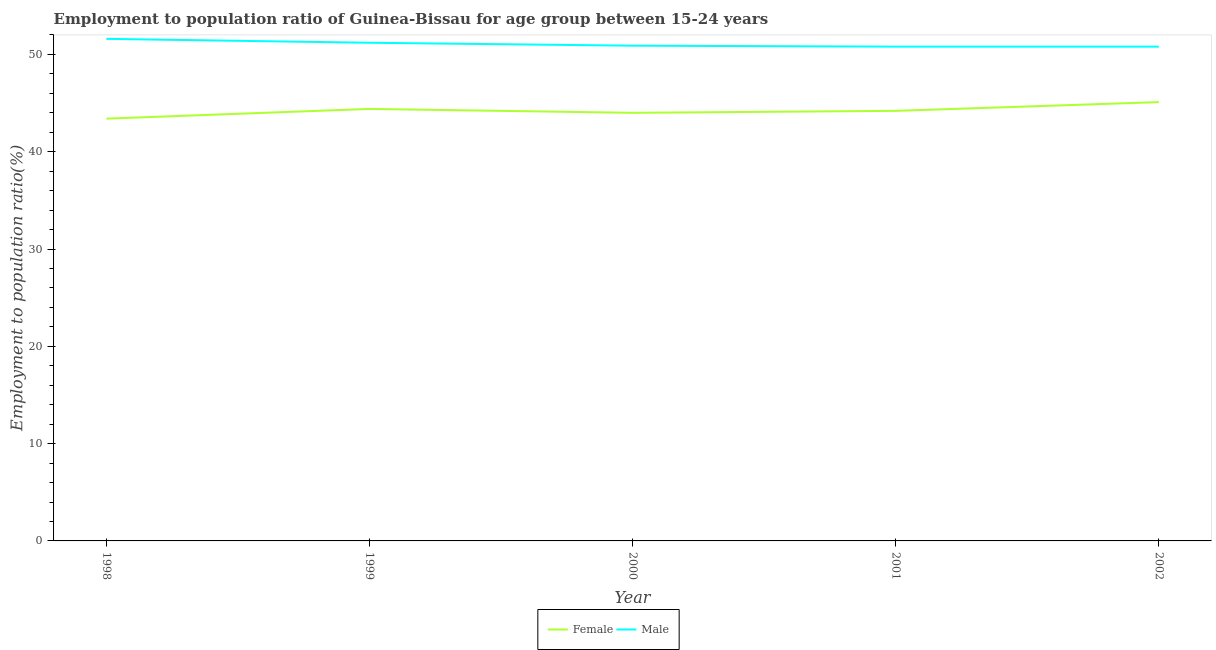Does the line corresponding to employment to population ratio(male) intersect with the line corresponding to employment to population ratio(female)?
Offer a very short reply. No. What is the employment to population ratio(female) in 1998?
Your response must be concise. 43.4. Across all years, what is the maximum employment to population ratio(male)?
Your response must be concise. 51.6. Across all years, what is the minimum employment to population ratio(male)?
Ensure brevity in your answer.  50.8. What is the total employment to population ratio(male) in the graph?
Offer a terse response. 255.3. What is the difference between the employment to population ratio(female) in 2000 and that in 2001?
Your answer should be very brief. -0.2. What is the difference between the employment to population ratio(female) in 2002 and the employment to population ratio(male) in 1999?
Your response must be concise. -6.1. What is the average employment to population ratio(male) per year?
Provide a short and direct response. 51.06. In the year 2001, what is the difference between the employment to population ratio(female) and employment to population ratio(male)?
Your answer should be compact. -6.6. In how many years, is the employment to population ratio(male) greater than 36 %?
Offer a very short reply. 5. What is the ratio of the employment to population ratio(male) in 1999 to that in 2000?
Your answer should be very brief. 1.01. Is the difference between the employment to population ratio(female) in 1998 and 2002 greater than the difference between the employment to population ratio(male) in 1998 and 2002?
Your answer should be very brief. No. What is the difference between the highest and the second highest employment to population ratio(male)?
Offer a very short reply. 0.4. What is the difference between the highest and the lowest employment to population ratio(male)?
Offer a very short reply. 0.8. In how many years, is the employment to population ratio(female) greater than the average employment to population ratio(female) taken over all years?
Your response must be concise. 2. What is the difference between two consecutive major ticks on the Y-axis?
Your response must be concise. 10. Are the values on the major ticks of Y-axis written in scientific E-notation?
Your response must be concise. No. Does the graph contain any zero values?
Keep it short and to the point. No. How are the legend labels stacked?
Ensure brevity in your answer.  Horizontal. What is the title of the graph?
Your response must be concise. Employment to population ratio of Guinea-Bissau for age group between 15-24 years. Does "Grants" appear as one of the legend labels in the graph?
Ensure brevity in your answer.  No. What is the label or title of the X-axis?
Ensure brevity in your answer.  Year. What is the label or title of the Y-axis?
Offer a very short reply. Employment to population ratio(%). What is the Employment to population ratio(%) of Female in 1998?
Offer a very short reply. 43.4. What is the Employment to population ratio(%) in Male in 1998?
Give a very brief answer. 51.6. What is the Employment to population ratio(%) of Female in 1999?
Offer a very short reply. 44.4. What is the Employment to population ratio(%) of Male in 1999?
Provide a short and direct response. 51.2. What is the Employment to population ratio(%) in Male in 2000?
Provide a succinct answer. 50.9. What is the Employment to population ratio(%) of Female in 2001?
Provide a succinct answer. 44.2. What is the Employment to population ratio(%) in Male in 2001?
Give a very brief answer. 50.8. What is the Employment to population ratio(%) in Female in 2002?
Provide a short and direct response. 45.1. What is the Employment to population ratio(%) in Male in 2002?
Give a very brief answer. 50.8. Across all years, what is the maximum Employment to population ratio(%) of Female?
Offer a very short reply. 45.1. Across all years, what is the maximum Employment to population ratio(%) in Male?
Your answer should be compact. 51.6. Across all years, what is the minimum Employment to population ratio(%) of Female?
Ensure brevity in your answer.  43.4. Across all years, what is the minimum Employment to population ratio(%) of Male?
Give a very brief answer. 50.8. What is the total Employment to population ratio(%) in Female in the graph?
Your answer should be very brief. 221.1. What is the total Employment to population ratio(%) in Male in the graph?
Ensure brevity in your answer.  255.3. What is the difference between the Employment to population ratio(%) in Female in 1998 and that in 1999?
Your answer should be very brief. -1. What is the difference between the Employment to population ratio(%) in Female in 1998 and that in 2000?
Offer a very short reply. -0.6. What is the difference between the Employment to population ratio(%) in Male in 1998 and that in 2000?
Provide a short and direct response. 0.7. What is the difference between the Employment to population ratio(%) in Male in 1998 and that in 2002?
Your answer should be compact. 0.8. What is the difference between the Employment to population ratio(%) of Female in 1999 and that in 2000?
Your answer should be compact. 0.4. What is the difference between the Employment to population ratio(%) of Male in 1999 and that in 2000?
Provide a succinct answer. 0.3. What is the difference between the Employment to population ratio(%) of Male in 1999 and that in 2001?
Your answer should be compact. 0.4. What is the difference between the Employment to population ratio(%) in Female in 2000 and that in 2002?
Your response must be concise. -1.1. What is the difference between the Employment to population ratio(%) of Male in 2000 and that in 2002?
Make the answer very short. 0.1. What is the difference between the Employment to population ratio(%) of Female in 1998 and the Employment to population ratio(%) of Male in 2000?
Give a very brief answer. -7.5. What is the difference between the Employment to population ratio(%) in Female in 1999 and the Employment to population ratio(%) in Male in 2000?
Offer a very short reply. -6.5. What is the difference between the Employment to population ratio(%) in Female in 2001 and the Employment to population ratio(%) in Male in 2002?
Your answer should be very brief. -6.6. What is the average Employment to population ratio(%) in Female per year?
Your answer should be compact. 44.22. What is the average Employment to population ratio(%) in Male per year?
Give a very brief answer. 51.06. In the year 1998, what is the difference between the Employment to population ratio(%) of Female and Employment to population ratio(%) of Male?
Ensure brevity in your answer.  -8.2. In the year 2000, what is the difference between the Employment to population ratio(%) in Female and Employment to population ratio(%) in Male?
Your response must be concise. -6.9. In the year 2001, what is the difference between the Employment to population ratio(%) of Female and Employment to population ratio(%) of Male?
Offer a very short reply. -6.6. What is the ratio of the Employment to population ratio(%) of Female in 1998 to that in 1999?
Your answer should be compact. 0.98. What is the ratio of the Employment to population ratio(%) in Female in 1998 to that in 2000?
Make the answer very short. 0.99. What is the ratio of the Employment to population ratio(%) in Male in 1998 to that in 2000?
Give a very brief answer. 1.01. What is the ratio of the Employment to population ratio(%) of Female in 1998 to that in 2001?
Your answer should be very brief. 0.98. What is the ratio of the Employment to population ratio(%) in Male in 1998 to that in 2001?
Your response must be concise. 1.02. What is the ratio of the Employment to population ratio(%) of Female in 1998 to that in 2002?
Offer a very short reply. 0.96. What is the ratio of the Employment to population ratio(%) of Male in 1998 to that in 2002?
Your answer should be very brief. 1.02. What is the ratio of the Employment to population ratio(%) in Female in 1999 to that in 2000?
Ensure brevity in your answer.  1.01. What is the ratio of the Employment to population ratio(%) in Male in 1999 to that in 2000?
Your answer should be compact. 1.01. What is the ratio of the Employment to population ratio(%) in Male in 1999 to that in 2001?
Offer a very short reply. 1.01. What is the ratio of the Employment to population ratio(%) of Female in 1999 to that in 2002?
Your response must be concise. 0.98. What is the ratio of the Employment to population ratio(%) in Male in 1999 to that in 2002?
Provide a short and direct response. 1.01. What is the ratio of the Employment to population ratio(%) in Male in 2000 to that in 2001?
Your response must be concise. 1. What is the ratio of the Employment to population ratio(%) of Female in 2000 to that in 2002?
Provide a short and direct response. 0.98. What is the ratio of the Employment to population ratio(%) of Male in 2000 to that in 2002?
Offer a very short reply. 1. What is the difference between the highest and the second highest Employment to population ratio(%) in Female?
Give a very brief answer. 0.7. What is the difference between the highest and the second highest Employment to population ratio(%) in Male?
Give a very brief answer. 0.4. What is the difference between the highest and the lowest Employment to population ratio(%) of Female?
Your answer should be compact. 1.7. What is the difference between the highest and the lowest Employment to population ratio(%) in Male?
Provide a short and direct response. 0.8. 